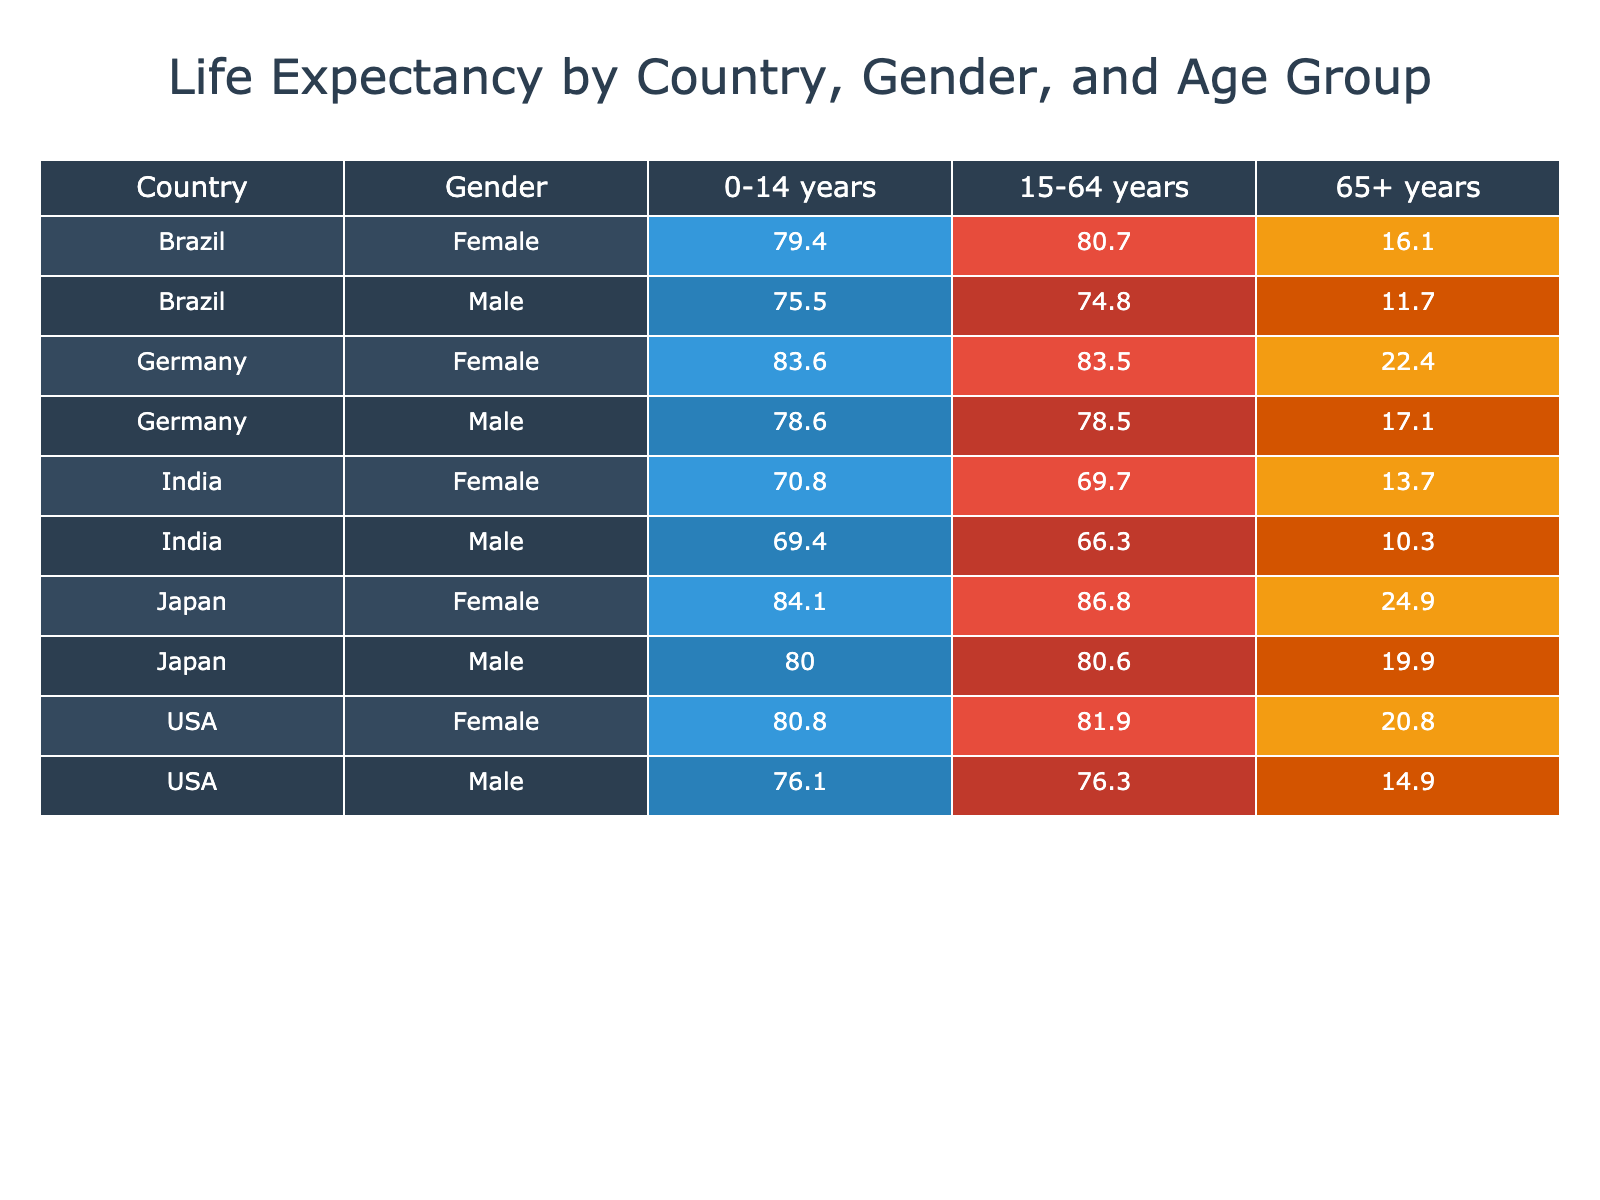What is the life expectancy for females aged 0-14 in Japan? Directly refer to the table; for Japan and the Female gender under the 0-14 age group, the life expectancy is given as 84.1.
Answer: 84.1 Which gender in the USA has a lower life expectancy for the age group 65+? Looking at the USA's data in the table, the life expectancy for Males aged 65+ is 14.9, while for Females it is 20.8. Therefore, Males have a lower life expectancy in this age group.
Answer: Males What is the average life expectancy of German Females across all age groups? For German Females: 83.6 (0-14) + 83.5 (15-64) + 22.4 (65+) = 189.5. There are 3 data points, so the average is 189.5 / 3 = 63.17.
Answer: 63.17 Is the life expectancy for Indian females aged 15-64 higher than that of Brazilian males in the same age group? For Indian Females aged 15-64, life expectancy is 69.7, while for Brazilian Males it is 74.8. 69.7 is not higher than 74.8.
Answer: No What is the difference in life expectancy between Japan and the USA for Males aged 15-64? For Japan, Males aged 15-64 have a life expectancy of 80.6, while for the USA, it is 76.3. The difference is 80.6 - 76.3 = 4.3.
Answer: 4.3 In which country do Females have the highest life expectancy in the age group 65+? Comparing the life expectancies for Females aged 65+ from Japan (24.9), Germany (22.4), Brazil (16.1), and India (13.7), Japan has the highest at 24.9.
Answer: Japan What is the combined life expectancy for Brazilian Males in all three age groups? Adding the life expectancies of Brazilian Males: 75.5 (0-14) + 74.8 (15-64) + 11.7 (65+) = 162. The combined life expectancy is 162.
Answer: 162 Are there any age groups where Indian Males have a higher life expectancy than Indian Females? Checking the values: 0-14 (69.4 vs 70.8), 15-64 (66.3 vs 69.7), and 65+ (10.3 vs 13.7); in all cases, Indian Males have lower life expectancies compared to Indian Females.
Answer: No Which country has the lowest life expectancy for Males in the age group 65+? Looking at the table, India has the lowest life expectancy for Males aged 65+ at 10.3, compared to Brazil (11.7), Germany (17.1), and Japan (19.9).
Answer: India 